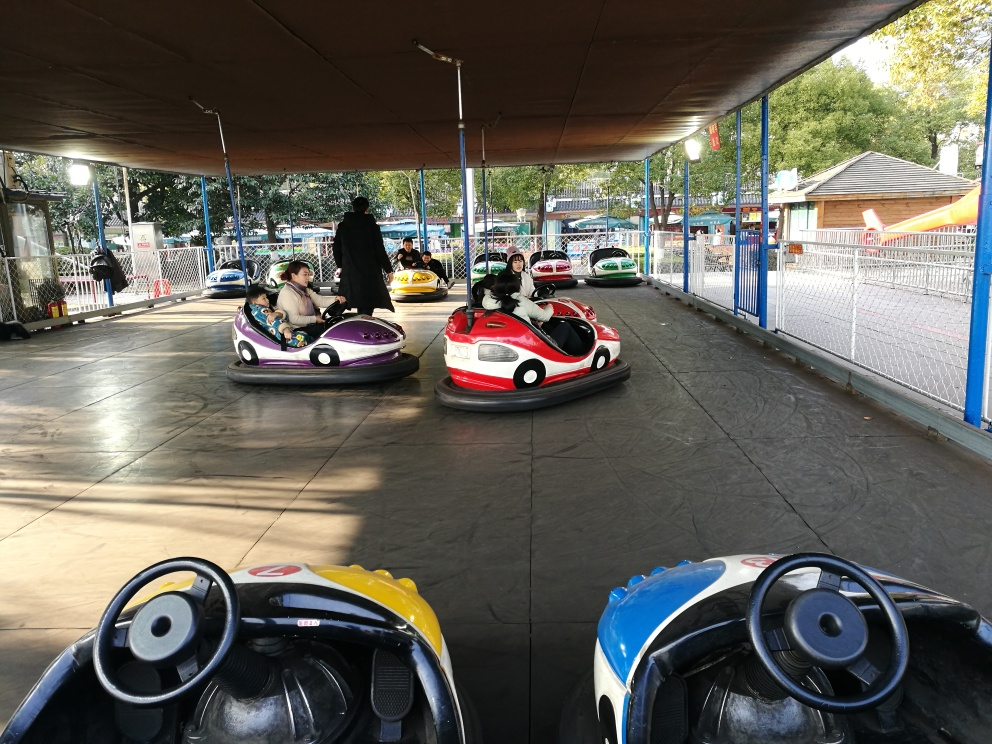Is the tone of this image harsh?
 false 